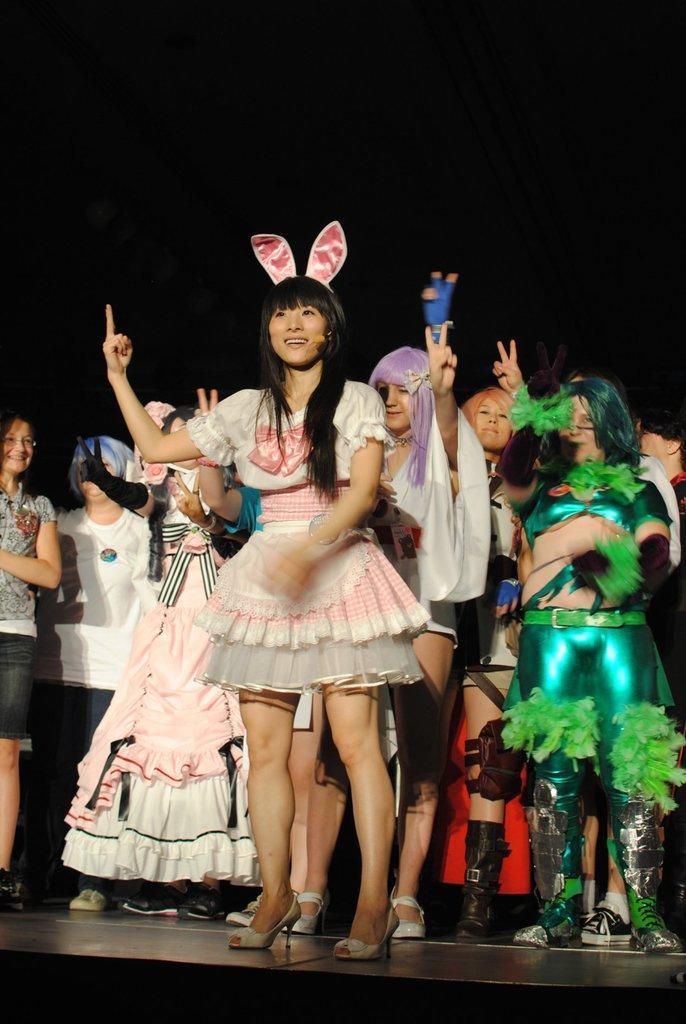Could you give a brief overview of what you see in this image? Here we can see group of people on the floor and there is a dark background. 